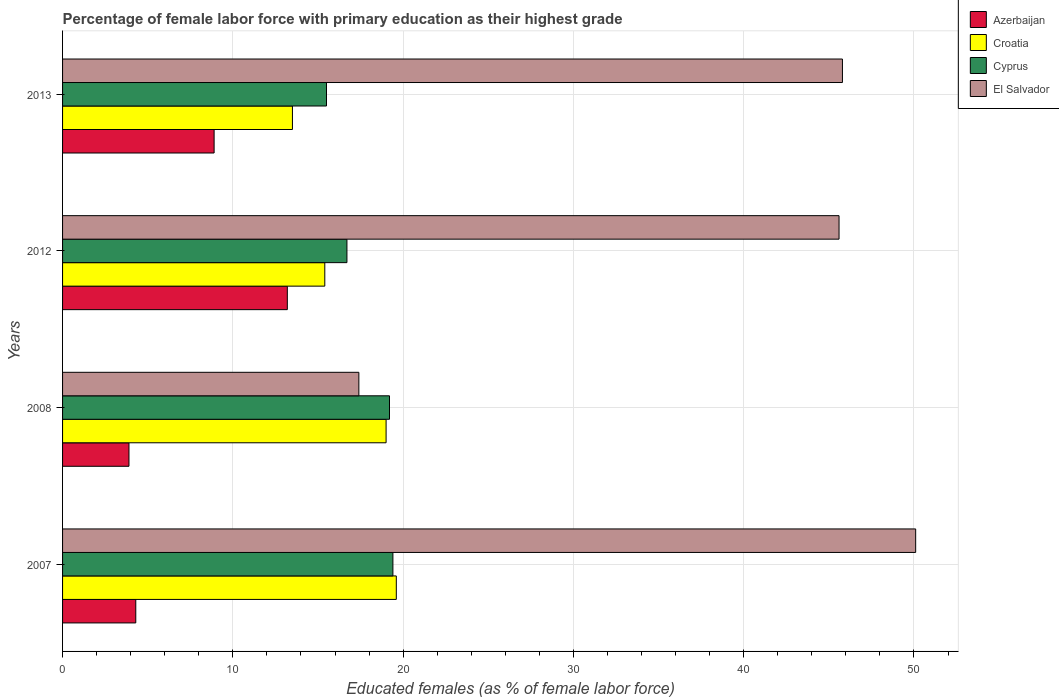Are the number of bars per tick equal to the number of legend labels?
Your answer should be very brief. Yes. Are the number of bars on each tick of the Y-axis equal?
Make the answer very short. Yes. How many bars are there on the 1st tick from the bottom?
Provide a succinct answer. 4. In how many cases, is the number of bars for a given year not equal to the number of legend labels?
Your answer should be compact. 0. What is the percentage of female labor force with primary education in Azerbaijan in 2013?
Give a very brief answer. 8.9. Across all years, what is the maximum percentage of female labor force with primary education in Cyprus?
Your answer should be very brief. 19.4. In which year was the percentage of female labor force with primary education in Cyprus minimum?
Provide a short and direct response. 2013. What is the total percentage of female labor force with primary education in El Salvador in the graph?
Your answer should be very brief. 158.9. What is the difference between the percentage of female labor force with primary education in Cyprus in 2008 and that in 2013?
Offer a terse response. 3.7. What is the difference between the percentage of female labor force with primary education in Cyprus in 2008 and the percentage of female labor force with primary education in El Salvador in 2012?
Your answer should be compact. -26.4. What is the average percentage of female labor force with primary education in Cyprus per year?
Ensure brevity in your answer.  17.7. In the year 2008, what is the difference between the percentage of female labor force with primary education in El Salvador and percentage of female labor force with primary education in Croatia?
Make the answer very short. -1.6. What is the ratio of the percentage of female labor force with primary education in Croatia in 2007 to that in 2008?
Give a very brief answer. 1.03. Is the percentage of female labor force with primary education in Azerbaijan in 2008 less than that in 2013?
Offer a very short reply. Yes. What is the difference between the highest and the second highest percentage of female labor force with primary education in El Salvador?
Keep it short and to the point. 4.3. What is the difference between the highest and the lowest percentage of female labor force with primary education in El Salvador?
Provide a short and direct response. 32.7. Is the sum of the percentage of female labor force with primary education in Azerbaijan in 2008 and 2012 greater than the maximum percentage of female labor force with primary education in El Salvador across all years?
Your answer should be very brief. No. Is it the case that in every year, the sum of the percentage of female labor force with primary education in Croatia and percentage of female labor force with primary education in Azerbaijan is greater than the sum of percentage of female labor force with primary education in Cyprus and percentage of female labor force with primary education in El Salvador?
Your response must be concise. No. What does the 2nd bar from the top in 2008 represents?
Offer a very short reply. Cyprus. What does the 1st bar from the bottom in 2013 represents?
Make the answer very short. Azerbaijan. Is it the case that in every year, the sum of the percentage of female labor force with primary education in El Salvador and percentage of female labor force with primary education in Croatia is greater than the percentage of female labor force with primary education in Cyprus?
Your response must be concise. Yes. How many bars are there?
Ensure brevity in your answer.  16. Are all the bars in the graph horizontal?
Provide a short and direct response. Yes. How many legend labels are there?
Ensure brevity in your answer.  4. What is the title of the graph?
Provide a short and direct response. Percentage of female labor force with primary education as their highest grade. What is the label or title of the X-axis?
Your response must be concise. Educated females (as % of female labor force). What is the Educated females (as % of female labor force) of Azerbaijan in 2007?
Provide a succinct answer. 4.3. What is the Educated females (as % of female labor force) of Croatia in 2007?
Provide a succinct answer. 19.6. What is the Educated females (as % of female labor force) of Cyprus in 2007?
Ensure brevity in your answer.  19.4. What is the Educated females (as % of female labor force) in El Salvador in 2007?
Your response must be concise. 50.1. What is the Educated females (as % of female labor force) of Azerbaijan in 2008?
Ensure brevity in your answer.  3.9. What is the Educated females (as % of female labor force) in Cyprus in 2008?
Keep it short and to the point. 19.2. What is the Educated females (as % of female labor force) of El Salvador in 2008?
Your response must be concise. 17.4. What is the Educated females (as % of female labor force) in Azerbaijan in 2012?
Make the answer very short. 13.2. What is the Educated females (as % of female labor force) in Croatia in 2012?
Make the answer very short. 15.4. What is the Educated females (as % of female labor force) of Cyprus in 2012?
Offer a terse response. 16.7. What is the Educated females (as % of female labor force) in El Salvador in 2012?
Make the answer very short. 45.6. What is the Educated females (as % of female labor force) of Azerbaijan in 2013?
Ensure brevity in your answer.  8.9. What is the Educated females (as % of female labor force) of Croatia in 2013?
Offer a terse response. 13.5. What is the Educated females (as % of female labor force) in Cyprus in 2013?
Offer a very short reply. 15.5. What is the Educated females (as % of female labor force) of El Salvador in 2013?
Provide a short and direct response. 45.8. Across all years, what is the maximum Educated females (as % of female labor force) of Azerbaijan?
Make the answer very short. 13.2. Across all years, what is the maximum Educated females (as % of female labor force) in Croatia?
Offer a terse response. 19.6. Across all years, what is the maximum Educated females (as % of female labor force) of Cyprus?
Provide a short and direct response. 19.4. Across all years, what is the maximum Educated females (as % of female labor force) in El Salvador?
Make the answer very short. 50.1. Across all years, what is the minimum Educated females (as % of female labor force) in Azerbaijan?
Your answer should be very brief. 3.9. Across all years, what is the minimum Educated females (as % of female labor force) of Cyprus?
Make the answer very short. 15.5. Across all years, what is the minimum Educated females (as % of female labor force) of El Salvador?
Your response must be concise. 17.4. What is the total Educated females (as % of female labor force) of Azerbaijan in the graph?
Your answer should be very brief. 30.3. What is the total Educated females (as % of female labor force) in Croatia in the graph?
Ensure brevity in your answer.  67.5. What is the total Educated females (as % of female labor force) in Cyprus in the graph?
Give a very brief answer. 70.8. What is the total Educated females (as % of female labor force) of El Salvador in the graph?
Offer a terse response. 158.9. What is the difference between the Educated females (as % of female labor force) in Azerbaijan in 2007 and that in 2008?
Your answer should be compact. 0.4. What is the difference between the Educated females (as % of female labor force) in El Salvador in 2007 and that in 2008?
Provide a short and direct response. 32.7. What is the difference between the Educated females (as % of female labor force) of Croatia in 2007 and that in 2012?
Your answer should be compact. 4.2. What is the difference between the Educated females (as % of female labor force) in Cyprus in 2007 and that in 2012?
Your answer should be compact. 2.7. What is the difference between the Educated females (as % of female labor force) in El Salvador in 2007 and that in 2012?
Your answer should be very brief. 4.5. What is the difference between the Educated females (as % of female labor force) of Croatia in 2007 and that in 2013?
Make the answer very short. 6.1. What is the difference between the Educated females (as % of female labor force) of Cyprus in 2007 and that in 2013?
Your answer should be very brief. 3.9. What is the difference between the Educated females (as % of female labor force) of Azerbaijan in 2008 and that in 2012?
Give a very brief answer. -9.3. What is the difference between the Educated females (as % of female labor force) of El Salvador in 2008 and that in 2012?
Offer a terse response. -28.2. What is the difference between the Educated females (as % of female labor force) of Cyprus in 2008 and that in 2013?
Your answer should be very brief. 3.7. What is the difference between the Educated females (as % of female labor force) of El Salvador in 2008 and that in 2013?
Keep it short and to the point. -28.4. What is the difference between the Educated females (as % of female labor force) of El Salvador in 2012 and that in 2013?
Your response must be concise. -0.2. What is the difference between the Educated females (as % of female labor force) in Azerbaijan in 2007 and the Educated females (as % of female labor force) in Croatia in 2008?
Offer a terse response. -14.7. What is the difference between the Educated females (as % of female labor force) in Azerbaijan in 2007 and the Educated females (as % of female labor force) in Cyprus in 2008?
Offer a terse response. -14.9. What is the difference between the Educated females (as % of female labor force) in Cyprus in 2007 and the Educated females (as % of female labor force) in El Salvador in 2008?
Make the answer very short. 2. What is the difference between the Educated females (as % of female labor force) in Azerbaijan in 2007 and the Educated females (as % of female labor force) in Cyprus in 2012?
Make the answer very short. -12.4. What is the difference between the Educated females (as % of female labor force) in Azerbaijan in 2007 and the Educated females (as % of female labor force) in El Salvador in 2012?
Your answer should be very brief. -41.3. What is the difference between the Educated females (as % of female labor force) in Cyprus in 2007 and the Educated females (as % of female labor force) in El Salvador in 2012?
Your answer should be compact. -26.2. What is the difference between the Educated females (as % of female labor force) of Azerbaijan in 2007 and the Educated females (as % of female labor force) of El Salvador in 2013?
Your answer should be compact. -41.5. What is the difference between the Educated females (as % of female labor force) in Croatia in 2007 and the Educated females (as % of female labor force) in El Salvador in 2013?
Your answer should be very brief. -26.2. What is the difference between the Educated females (as % of female labor force) of Cyprus in 2007 and the Educated females (as % of female labor force) of El Salvador in 2013?
Offer a terse response. -26.4. What is the difference between the Educated females (as % of female labor force) in Azerbaijan in 2008 and the Educated females (as % of female labor force) in Croatia in 2012?
Provide a short and direct response. -11.5. What is the difference between the Educated females (as % of female labor force) of Azerbaijan in 2008 and the Educated females (as % of female labor force) of El Salvador in 2012?
Keep it short and to the point. -41.7. What is the difference between the Educated females (as % of female labor force) of Croatia in 2008 and the Educated females (as % of female labor force) of Cyprus in 2012?
Provide a succinct answer. 2.3. What is the difference between the Educated females (as % of female labor force) in Croatia in 2008 and the Educated females (as % of female labor force) in El Salvador in 2012?
Provide a succinct answer. -26.6. What is the difference between the Educated females (as % of female labor force) in Cyprus in 2008 and the Educated females (as % of female labor force) in El Salvador in 2012?
Make the answer very short. -26.4. What is the difference between the Educated females (as % of female labor force) of Azerbaijan in 2008 and the Educated females (as % of female labor force) of El Salvador in 2013?
Offer a very short reply. -41.9. What is the difference between the Educated females (as % of female labor force) of Croatia in 2008 and the Educated females (as % of female labor force) of El Salvador in 2013?
Provide a succinct answer. -26.8. What is the difference between the Educated females (as % of female labor force) of Cyprus in 2008 and the Educated females (as % of female labor force) of El Salvador in 2013?
Your answer should be very brief. -26.6. What is the difference between the Educated females (as % of female labor force) of Azerbaijan in 2012 and the Educated females (as % of female labor force) of Croatia in 2013?
Keep it short and to the point. -0.3. What is the difference between the Educated females (as % of female labor force) of Azerbaijan in 2012 and the Educated females (as % of female labor force) of Cyprus in 2013?
Your answer should be very brief. -2.3. What is the difference between the Educated females (as % of female labor force) of Azerbaijan in 2012 and the Educated females (as % of female labor force) of El Salvador in 2013?
Your answer should be very brief. -32.6. What is the difference between the Educated females (as % of female labor force) of Croatia in 2012 and the Educated females (as % of female labor force) of Cyprus in 2013?
Provide a short and direct response. -0.1. What is the difference between the Educated females (as % of female labor force) of Croatia in 2012 and the Educated females (as % of female labor force) of El Salvador in 2013?
Your answer should be compact. -30.4. What is the difference between the Educated females (as % of female labor force) of Cyprus in 2012 and the Educated females (as % of female labor force) of El Salvador in 2013?
Give a very brief answer. -29.1. What is the average Educated females (as % of female labor force) of Azerbaijan per year?
Make the answer very short. 7.58. What is the average Educated females (as % of female labor force) of Croatia per year?
Your answer should be very brief. 16.88. What is the average Educated females (as % of female labor force) in Cyprus per year?
Provide a succinct answer. 17.7. What is the average Educated females (as % of female labor force) of El Salvador per year?
Keep it short and to the point. 39.73. In the year 2007, what is the difference between the Educated females (as % of female labor force) in Azerbaijan and Educated females (as % of female labor force) in Croatia?
Keep it short and to the point. -15.3. In the year 2007, what is the difference between the Educated females (as % of female labor force) in Azerbaijan and Educated females (as % of female labor force) in Cyprus?
Give a very brief answer. -15.1. In the year 2007, what is the difference between the Educated females (as % of female labor force) of Azerbaijan and Educated females (as % of female labor force) of El Salvador?
Offer a terse response. -45.8. In the year 2007, what is the difference between the Educated females (as % of female labor force) in Croatia and Educated females (as % of female labor force) in El Salvador?
Your answer should be compact. -30.5. In the year 2007, what is the difference between the Educated females (as % of female labor force) of Cyprus and Educated females (as % of female labor force) of El Salvador?
Give a very brief answer. -30.7. In the year 2008, what is the difference between the Educated females (as % of female labor force) of Azerbaijan and Educated females (as % of female labor force) of Croatia?
Provide a succinct answer. -15.1. In the year 2008, what is the difference between the Educated females (as % of female labor force) in Azerbaijan and Educated females (as % of female labor force) in Cyprus?
Your response must be concise. -15.3. In the year 2008, what is the difference between the Educated females (as % of female labor force) of Croatia and Educated females (as % of female labor force) of El Salvador?
Give a very brief answer. 1.6. In the year 2008, what is the difference between the Educated females (as % of female labor force) in Cyprus and Educated females (as % of female labor force) in El Salvador?
Offer a terse response. 1.8. In the year 2012, what is the difference between the Educated females (as % of female labor force) in Azerbaijan and Educated females (as % of female labor force) in Croatia?
Your answer should be very brief. -2.2. In the year 2012, what is the difference between the Educated females (as % of female labor force) in Azerbaijan and Educated females (as % of female labor force) in Cyprus?
Your answer should be very brief. -3.5. In the year 2012, what is the difference between the Educated females (as % of female labor force) of Azerbaijan and Educated females (as % of female labor force) of El Salvador?
Provide a short and direct response. -32.4. In the year 2012, what is the difference between the Educated females (as % of female labor force) of Croatia and Educated females (as % of female labor force) of El Salvador?
Your response must be concise. -30.2. In the year 2012, what is the difference between the Educated females (as % of female labor force) in Cyprus and Educated females (as % of female labor force) in El Salvador?
Provide a succinct answer. -28.9. In the year 2013, what is the difference between the Educated females (as % of female labor force) in Azerbaijan and Educated females (as % of female labor force) in Croatia?
Keep it short and to the point. -4.6. In the year 2013, what is the difference between the Educated females (as % of female labor force) in Azerbaijan and Educated females (as % of female labor force) in El Salvador?
Provide a succinct answer. -36.9. In the year 2013, what is the difference between the Educated females (as % of female labor force) of Croatia and Educated females (as % of female labor force) of Cyprus?
Your response must be concise. -2. In the year 2013, what is the difference between the Educated females (as % of female labor force) in Croatia and Educated females (as % of female labor force) in El Salvador?
Provide a short and direct response. -32.3. In the year 2013, what is the difference between the Educated females (as % of female labor force) in Cyprus and Educated females (as % of female labor force) in El Salvador?
Offer a terse response. -30.3. What is the ratio of the Educated females (as % of female labor force) in Azerbaijan in 2007 to that in 2008?
Your answer should be compact. 1.1. What is the ratio of the Educated females (as % of female labor force) of Croatia in 2007 to that in 2008?
Provide a short and direct response. 1.03. What is the ratio of the Educated females (as % of female labor force) of Cyprus in 2007 to that in 2008?
Provide a succinct answer. 1.01. What is the ratio of the Educated females (as % of female labor force) in El Salvador in 2007 to that in 2008?
Offer a very short reply. 2.88. What is the ratio of the Educated females (as % of female labor force) in Azerbaijan in 2007 to that in 2012?
Make the answer very short. 0.33. What is the ratio of the Educated females (as % of female labor force) of Croatia in 2007 to that in 2012?
Keep it short and to the point. 1.27. What is the ratio of the Educated females (as % of female labor force) of Cyprus in 2007 to that in 2012?
Ensure brevity in your answer.  1.16. What is the ratio of the Educated females (as % of female labor force) of El Salvador in 2007 to that in 2012?
Keep it short and to the point. 1.1. What is the ratio of the Educated females (as % of female labor force) in Azerbaijan in 2007 to that in 2013?
Your answer should be very brief. 0.48. What is the ratio of the Educated females (as % of female labor force) in Croatia in 2007 to that in 2013?
Give a very brief answer. 1.45. What is the ratio of the Educated females (as % of female labor force) in Cyprus in 2007 to that in 2013?
Give a very brief answer. 1.25. What is the ratio of the Educated females (as % of female labor force) in El Salvador in 2007 to that in 2013?
Your response must be concise. 1.09. What is the ratio of the Educated females (as % of female labor force) in Azerbaijan in 2008 to that in 2012?
Offer a terse response. 0.3. What is the ratio of the Educated females (as % of female labor force) of Croatia in 2008 to that in 2012?
Give a very brief answer. 1.23. What is the ratio of the Educated females (as % of female labor force) in Cyprus in 2008 to that in 2012?
Your answer should be compact. 1.15. What is the ratio of the Educated females (as % of female labor force) of El Salvador in 2008 to that in 2012?
Your response must be concise. 0.38. What is the ratio of the Educated females (as % of female labor force) of Azerbaijan in 2008 to that in 2013?
Offer a terse response. 0.44. What is the ratio of the Educated females (as % of female labor force) in Croatia in 2008 to that in 2013?
Provide a short and direct response. 1.41. What is the ratio of the Educated females (as % of female labor force) of Cyprus in 2008 to that in 2013?
Your answer should be compact. 1.24. What is the ratio of the Educated females (as % of female labor force) in El Salvador in 2008 to that in 2013?
Provide a succinct answer. 0.38. What is the ratio of the Educated females (as % of female labor force) in Azerbaijan in 2012 to that in 2013?
Offer a terse response. 1.48. What is the ratio of the Educated females (as % of female labor force) in Croatia in 2012 to that in 2013?
Offer a very short reply. 1.14. What is the ratio of the Educated females (as % of female labor force) in Cyprus in 2012 to that in 2013?
Provide a short and direct response. 1.08. What is the ratio of the Educated females (as % of female labor force) of El Salvador in 2012 to that in 2013?
Your answer should be compact. 1. What is the difference between the highest and the second highest Educated females (as % of female labor force) in Azerbaijan?
Give a very brief answer. 4.3. What is the difference between the highest and the lowest Educated females (as % of female labor force) of Azerbaijan?
Provide a short and direct response. 9.3. What is the difference between the highest and the lowest Educated females (as % of female labor force) of Cyprus?
Make the answer very short. 3.9. What is the difference between the highest and the lowest Educated females (as % of female labor force) in El Salvador?
Provide a succinct answer. 32.7. 